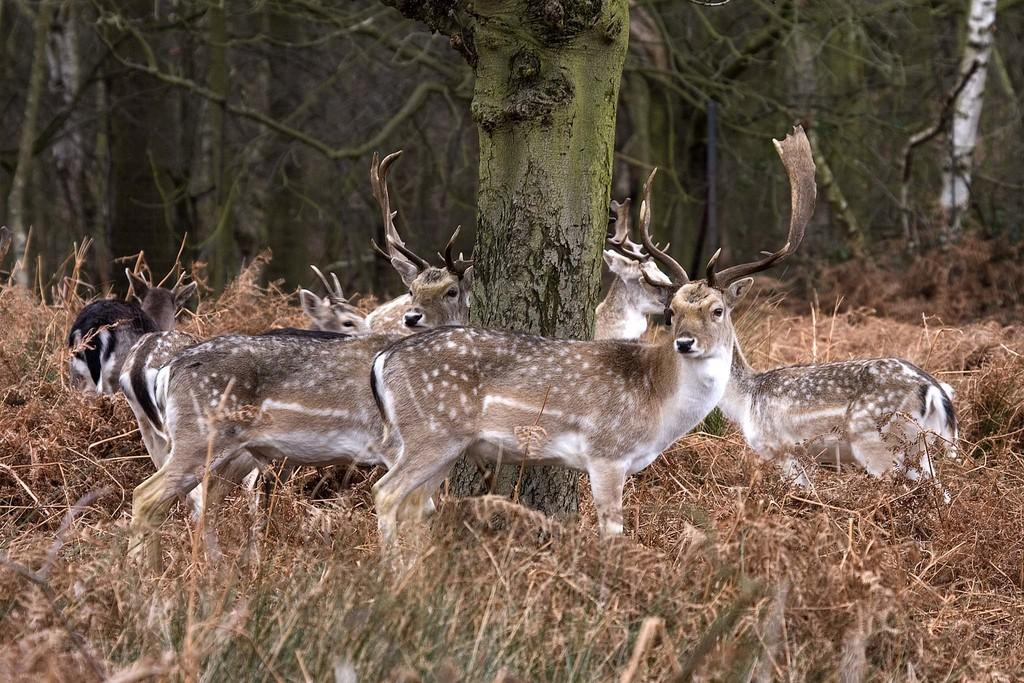What type of animals can be seen in the image? There are animals in the image, with white, brown, and black colors. What is the ground surface like where the animals are standing? The animals are standing on dried grass. What can be seen in the background of the image? There is a trunk and many trees visible in the background of the image. What type of current is flowing through the animals in the image? There is no current visible in the image; the animals are standing on dried grass. 